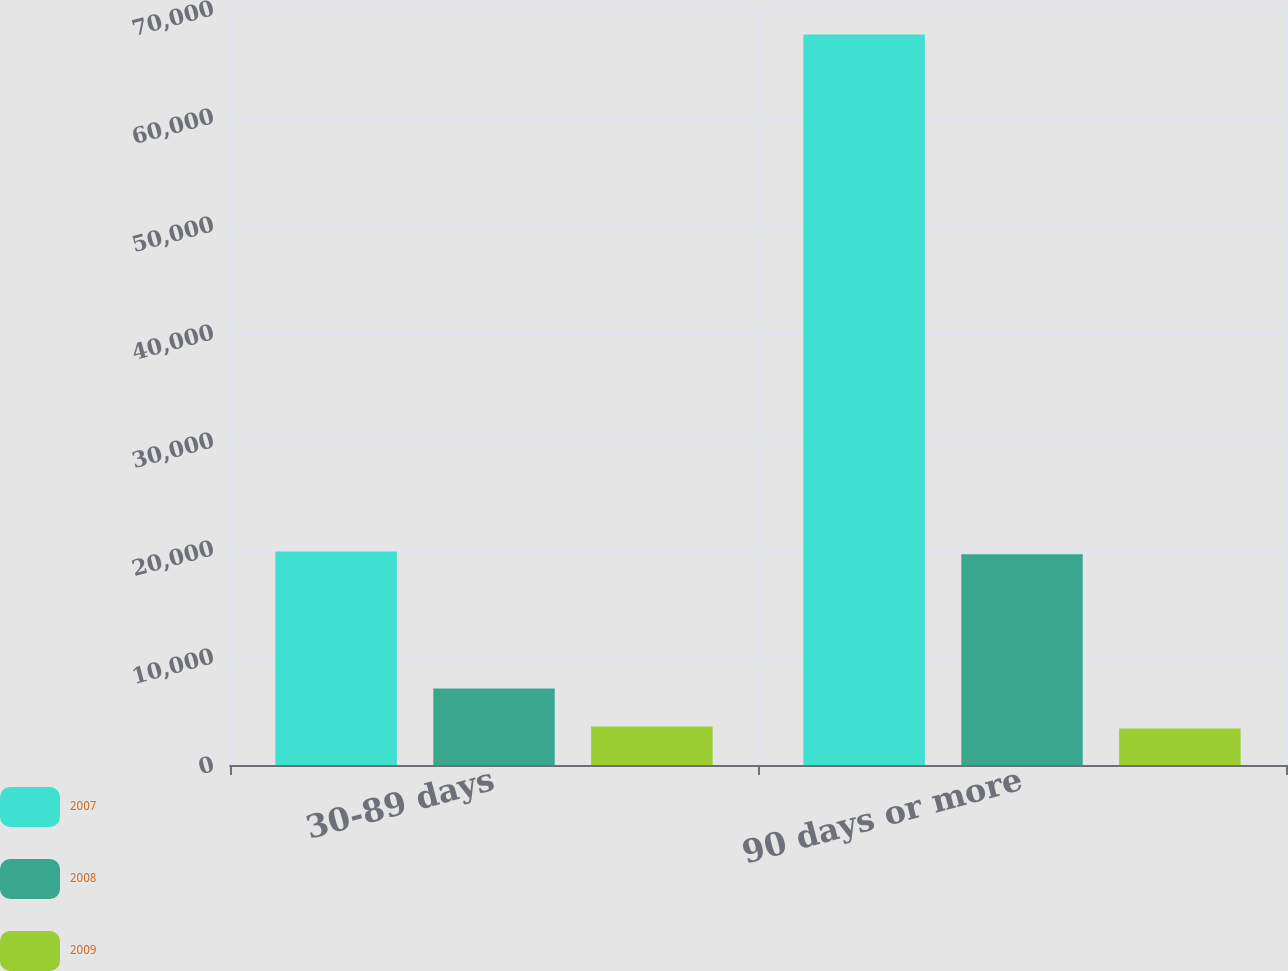Convert chart to OTSL. <chart><loc_0><loc_0><loc_500><loc_500><stacked_bar_chart><ecel><fcel>30-89 days<fcel>90 days or more<nl><fcel>2007<fcel>19767<fcel>67640<nl><fcel>2008<fcel>7087<fcel>19507<nl><fcel>2009<fcel>3569<fcel>3384<nl></chart> 